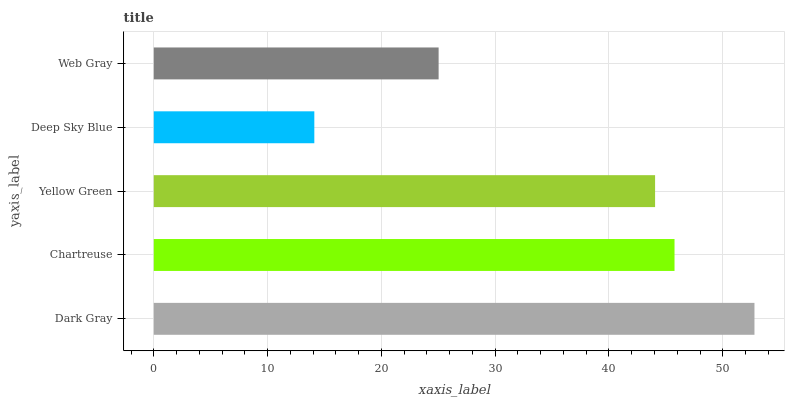Is Deep Sky Blue the minimum?
Answer yes or no. Yes. Is Dark Gray the maximum?
Answer yes or no. Yes. Is Chartreuse the minimum?
Answer yes or no. No. Is Chartreuse the maximum?
Answer yes or no. No. Is Dark Gray greater than Chartreuse?
Answer yes or no. Yes. Is Chartreuse less than Dark Gray?
Answer yes or no. Yes. Is Chartreuse greater than Dark Gray?
Answer yes or no. No. Is Dark Gray less than Chartreuse?
Answer yes or no. No. Is Yellow Green the high median?
Answer yes or no. Yes. Is Yellow Green the low median?
Answer yes or no. Yes. Is Deep Sky Blue the high median?
Answer yes or no. No. Is Web Gray the low median?
Answer yes or no. No. 